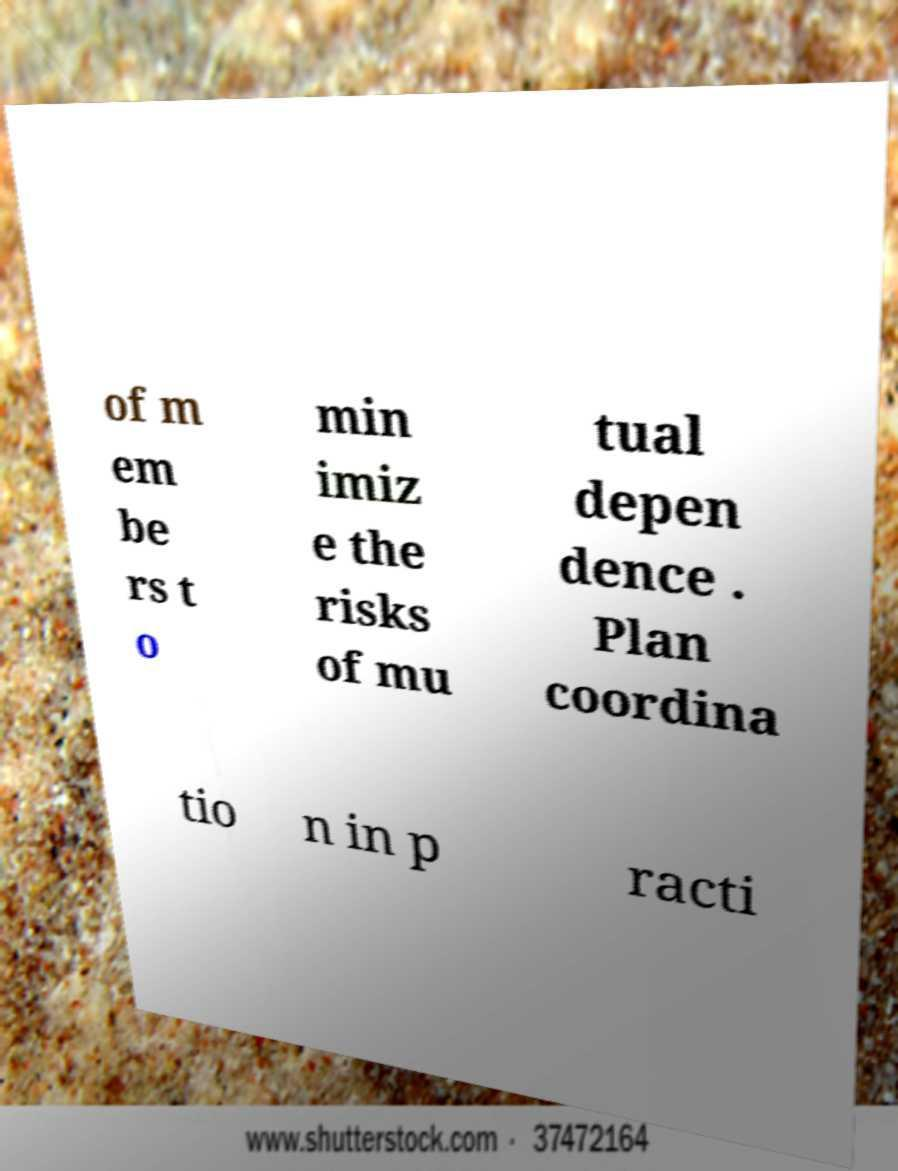Please identify and transcribe the text found in this image. of m em be rs t o min imiz e the risks of mu tual depen dence . Plan coordina tio n in p racti 